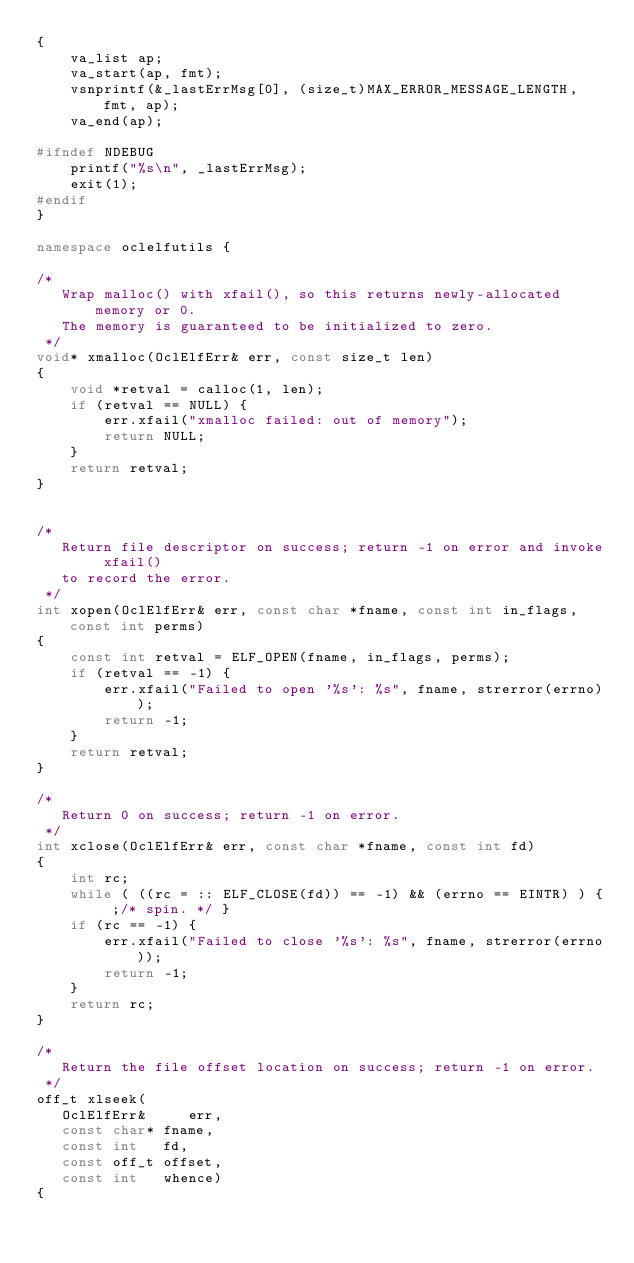Convert code to text. <code><loc_0><loc_0><loc_500><loc_500><_C++_>{
    va_list ap;
    va_start(ap, fmt);
    vsnprintf(&_lastErrMsg[0], (size_t)MAX_ERROR_MESSAGE_LENGTH, fmt, ap);
    va_end(ap);

#ifndef NDEBUG
    printf("%s\n", _lastErrMsg);
    exit(1);
#endif  
}

namespace oclelfutils {

/*
   Wrap malloc() with xfail(), so this returns newly-allocated memory or 0.
   The memory is guaranteed to be initialized to zero.
 */
void* xmalloc(OclElfErr& err, const size_t len)
{
    void *retval = calloc(1, len);
    if (retval == NULL) {
        err.xfail("xmalloc failed: out of memory");
        return NULL;
    }    
    return retval;
}


/*
   Return file descriptor on success; return -1 on error and invoke xfail()
   to record the error.
 */
int xopen(OclElfErr& err, const char *fname, const int in_flags, const int perms)
{
    const int retval = ELF_OPEN(fname, in_flags, perms);
    if (retval == -1) {
        err.xfail("Failed to open '%s': %s", fname, strerror(errno));
        return -1;
    }
    return retval;
}

/*
   Return 0 on success; return -1 on error.
 */
int xclose(OclElfErr& err, const char *fname, const int fd)
{
    int rc;
    while ( ((rc = :: ELF_CLOSE(fd)) == -1) && (errno == EINTR) ) { ;/* spin. */ }
    if (rc == -1) {
        err.xfail("Failed to close '%s': %s", fname, strerror(errno));
        return -1;
    }
    return rc;    
}

/*
   Return the file offset location on success; return -1 on error.
 */
off_t xlseek(
   OclElfErr&     err, 
   const char* fname, 
   const int   fd,
   const off_t offset, 
   const int   whence)
{</code> 